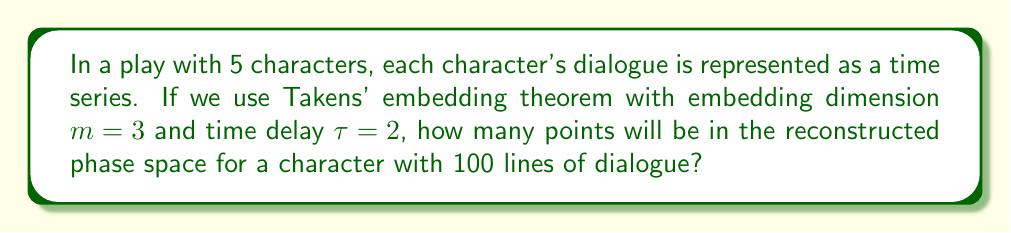Solve this math problem. To solve this problem, we need to understand the principles of phase space reconstruction using Takens' embedding theorem:

1) First, recall that Takens' embedding theorem allows us to reconstruct the phase space of a dynamical system from a single time series.

2) The embedding dimension $m$ represents the number of coordinates used to represent each point in the reconstructed phase space.

3) The time delay $\tau$ determines the spacing between the elements of the time series used to create each point.

4) Given a time series $x(t)$, each point in the reconstructed phase space is of the form:

   $$(x(t), x(t+\tau), x(t+2\tau), ..., x(t+(m-1)\tau))$$

5) In this case, we have:
   - Embedding dimension $m = 3$
   - Time delay $\tau = 2$
   - Total number of lines (data points) $N = 100$

6) The number of points in the reconstructed phase space is determined by how many complete sets of $m$ coordinates we can form from the time series.

7) The last point in the reconstructed space will use the last element of the original time series as its last coordinate. So, we can calculate the number of points as:

   $$N - (m-1)\tau = 100 - (3-1)2 = 100 - 4 = 96$$

Therefore, there will be 96 points in the reconstructed phase space for each character.
Answer: 96 points 